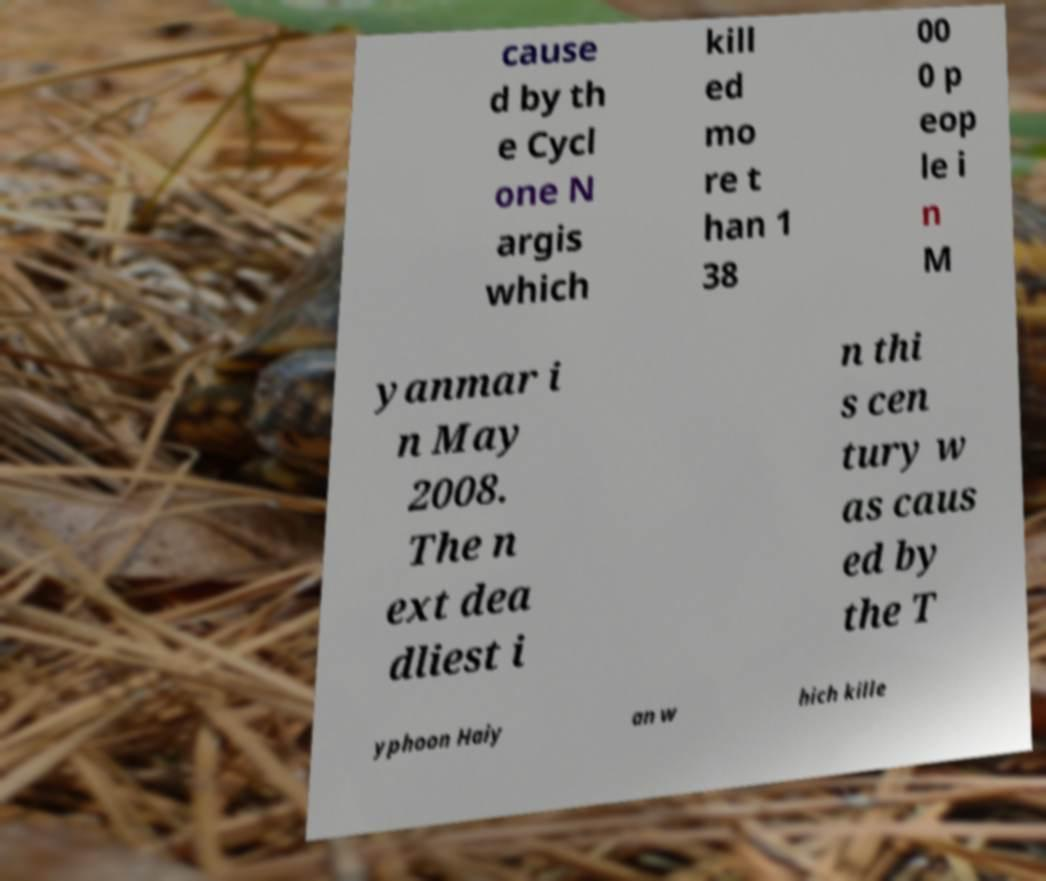Please identify and transcribe the text found in this image. cause d by th e Cycl one N argis which kill ed mo re t han 1 38 00 0 p eop le i n M yanmar i n May 2008. The n ext dea dliest i n thi s cen tury w as caus ed by the T yphoon Haiy an w hich kille 